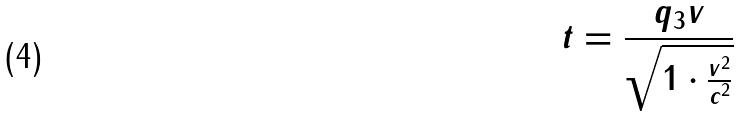Convert formula to latex. <formula><loc_0><loc_0><loc_500><loc_500>t = \frac { q _ { 3 } v } { \sqrt { 1 \cdot \frac { v ^ { 2 } } { c ^ { 2 } } } }</formula> 